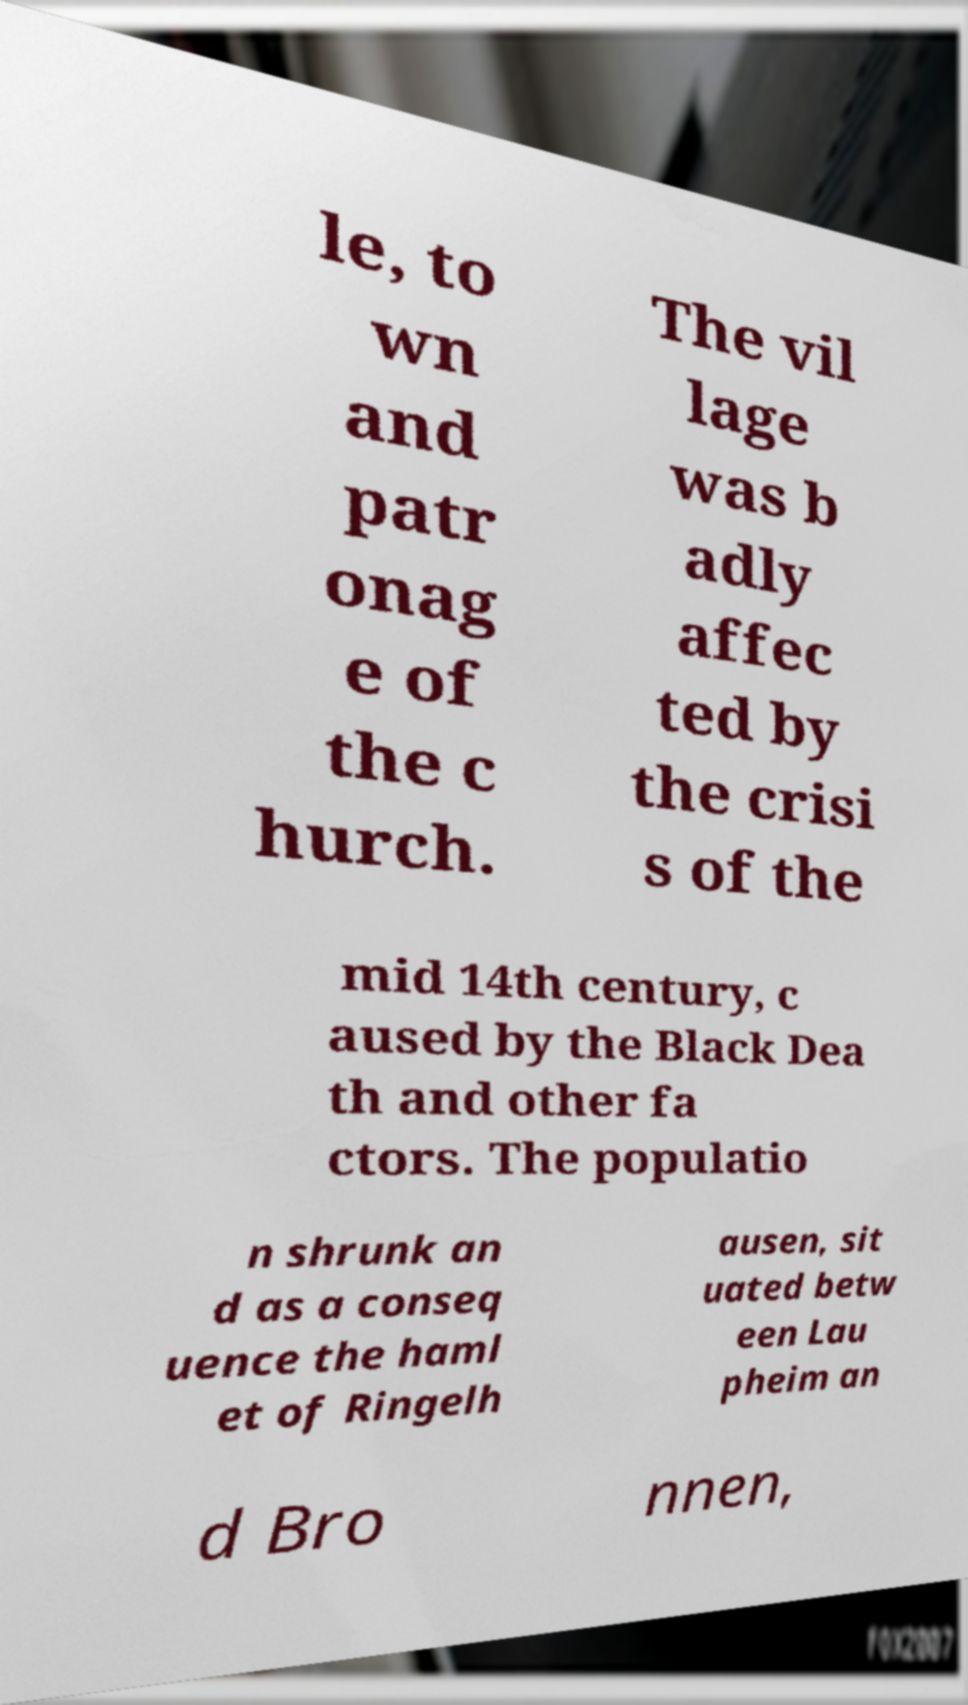Please read and relay the text visible in this image. What does it say? le, to wn and patr onag e of the c hurch. The vil lage was b adly affec ted by the crisi s of the mid 14th century, c aused by the Black Dea th and other fa ctors. The populatio n shrunk an d as a conseq uence the haml et of Ringelh ausen, sit uated betw een Lau pheim an d Bro nnen, 